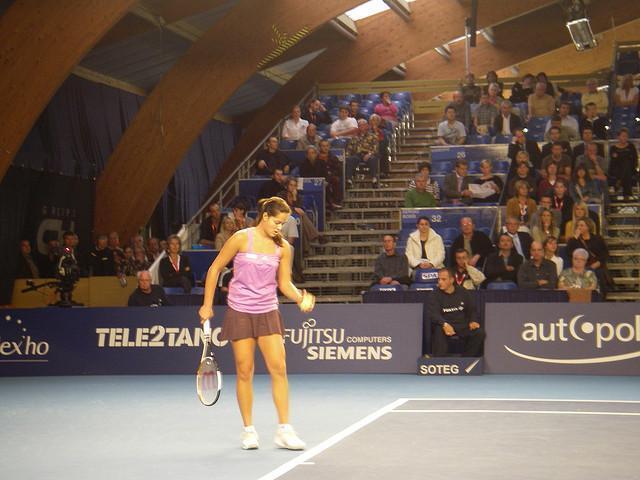How many people can be seen?
Give a very brief answer. 2. 